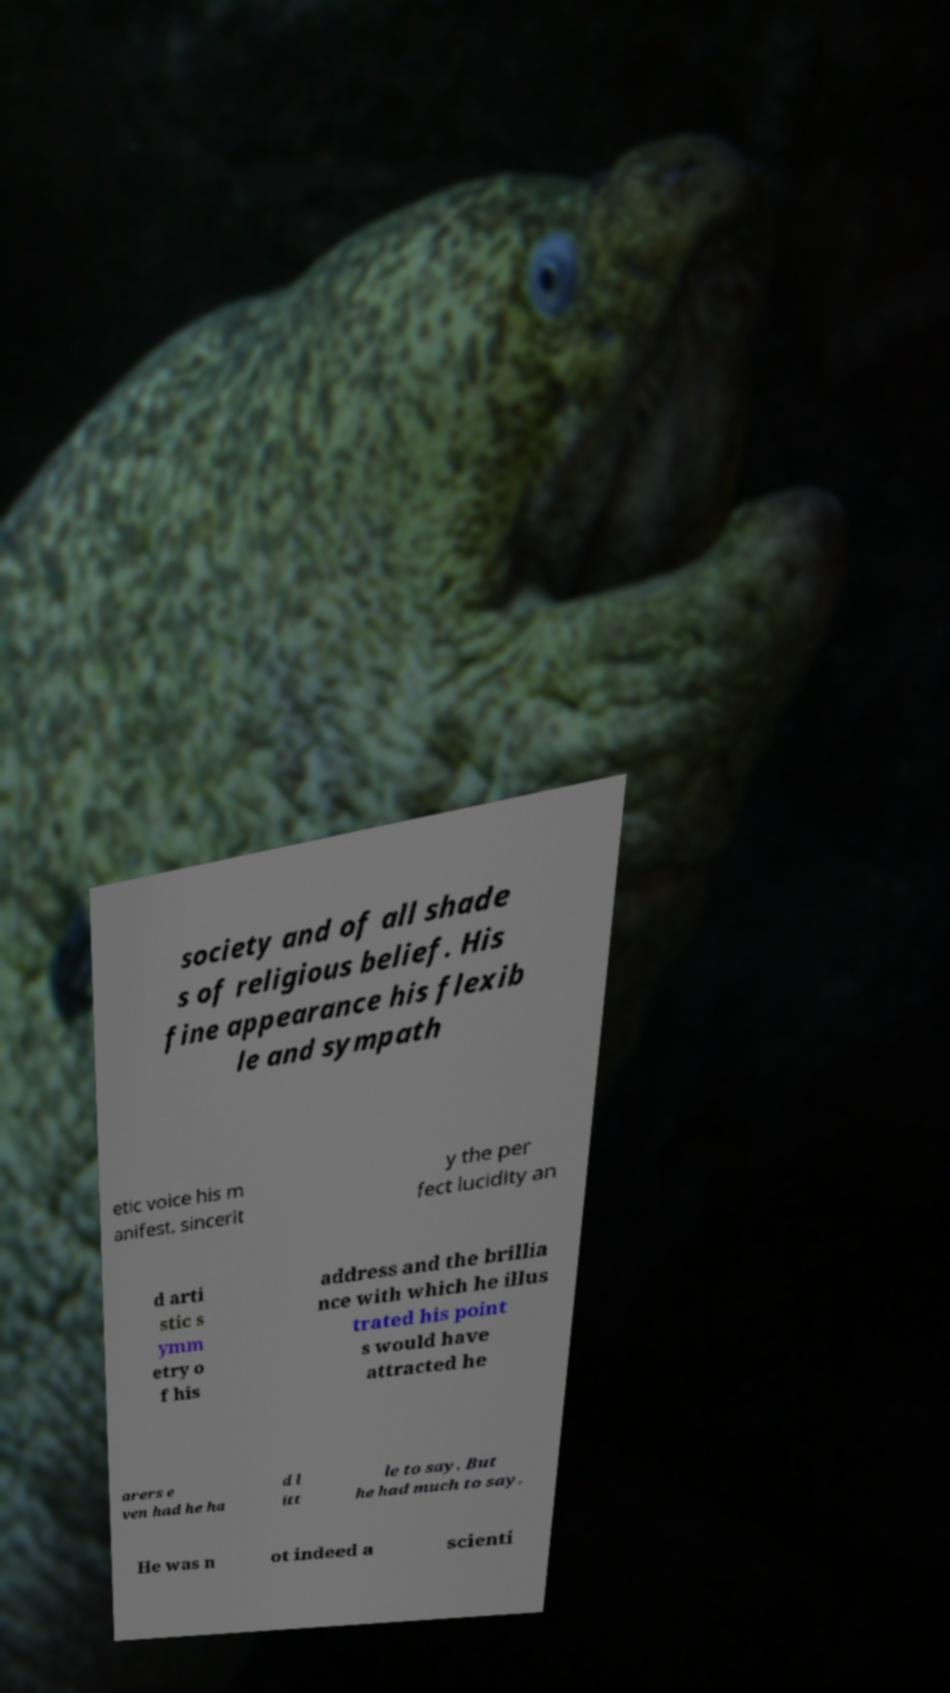What messages or text are displayed in this image? I need them in a readable, typed format. society and of all shade s of religious belief. His fine appearance his flexib le and sympath etic voice his m anifest. sincerit y the per fect lucidity an d arti stic s ymm etry o f his address and the brillia nce with which he illus trated his point s would have attracted he arers e ven had he ha d l itt le to say. But he had much to say. He was n ot indeed a scienti 